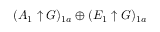Convert formula to latex. <formula><loc_0><loc_0><loc_500><loc_500>( A _ { 1 } \uparrow G ) _ { 1 a } \oplus ( E _ { 1 } \uparrow G ) _ { 1 a }</formula> 